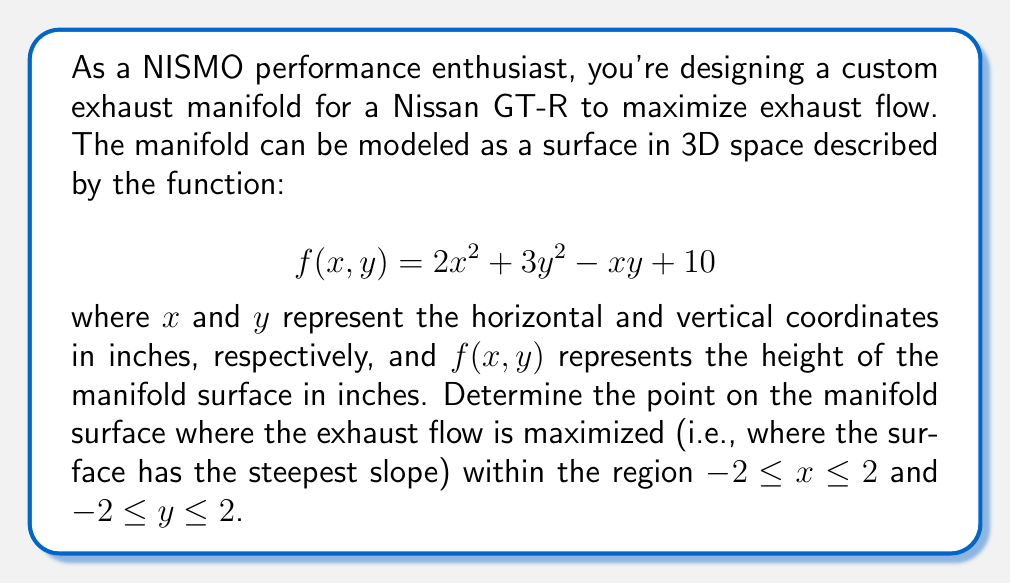Could you help me with this problem? To solve this problem, we'll use multivariable calculus to find the point of maximum slope on the manifold surface. Here's the step-by-step approach:

1) First, we need to calculate the gradient of the function $f(x,y)$. The gradient gives us the direction of steepest ascent at any point on the surface.

   $$\nabla f = \left(\frac{\partial f}{\partial x}, \frac{\partial f}{\partial y}\right)$$

2) Let's calculate the partial derivatives:

   $$\frac{\partial f}{\partial x} = 4x - y$$
   $$\frac{\partial f}{\partial y} = 6y - x$$

3) Now we have the gradient vector:

   $$\nabla f = (4x - y, 6y - x)$$

4) The magnitude of the gradient vector gives us the slope of the surface at any point:

   $$\|\nabla f\| = \sqrt{(4x - y)^2 + (6y - x)^2}$$

5) To find the maximum slope, we need to maximize this function within the given region. We can do this by finding the critical points and checking the boundaries.

6) To find critical points, we set both partial derivatives of $\|\nabla f\|$ to zero:

   $$\frac{\partial}{\partial x}\|\nabla f\| = \frac{(4x - y)(4) + (6y - x)(-1)}{\sqrt{(4x - y)^2 + (6y - x)^2}} = 0$$
   $$\frac{\partial}{\partial y}\|\nabla f\| = \frac{(4x - y)(-1) + (6y - x)(6)}{\sqrt{(4x - y)^2 + (6y - x)^2}} = 0$$

7) Solving these equations simultaneously is complex, so let's check the boundaries instead.

8) On the boundaries, we have four line segments to check:
   - $x = -2$, $-2 \leq y \leq 2$
   - $x = 2$, $-2 \leq y \leq 2$
   - $y = -2$, $-2 \leq x \leq 2$
   - $y = 2$, $-2 \leq x \leq 2$

9) Evaluating $\|\nabla f\|$ at the corners:
   - At (-2, -2): $\|\nabla f\| = \sqrt{(-8 + 2)^2 + (-12 + 2)^2} = \sqrt{36 + 100} = \sqrt{136} \approx 11.66$
   - At (-2, 2): $\|\nabla f\| = \sqrt{(-8 - 2)^2 + (12 + 2)^2} = \sqrt{100 + 196} = \sqrt{296} \approx 17.20$
   - At (2, -2): $\|\nabla f\| = \sqrt{(8 + 2)^2 + (-12 - 2)^2} = \sqrt{100 + 196} = \sqrt{296} \approx 17.20$
   - At (2, 2): $\|\nabla f\| = \sqrt{(8 - 2)^2 + (12 - 2)^2} = \sqrt{36 + 100} = \sqrt{136} \approx 11.66$

10) The maximum value occurs at both (-2, 2) and (2, -2), with a slope of $\sqrt{296} \approx 17.20$.
Answer: The exhaust flow is maximized (i.e., the manifold surface has the steepest slope) at two points: (-2, 2) and (2, -2), with a maximum slope of $\sqrt{296} \approx 17.20$ inches per inch. 